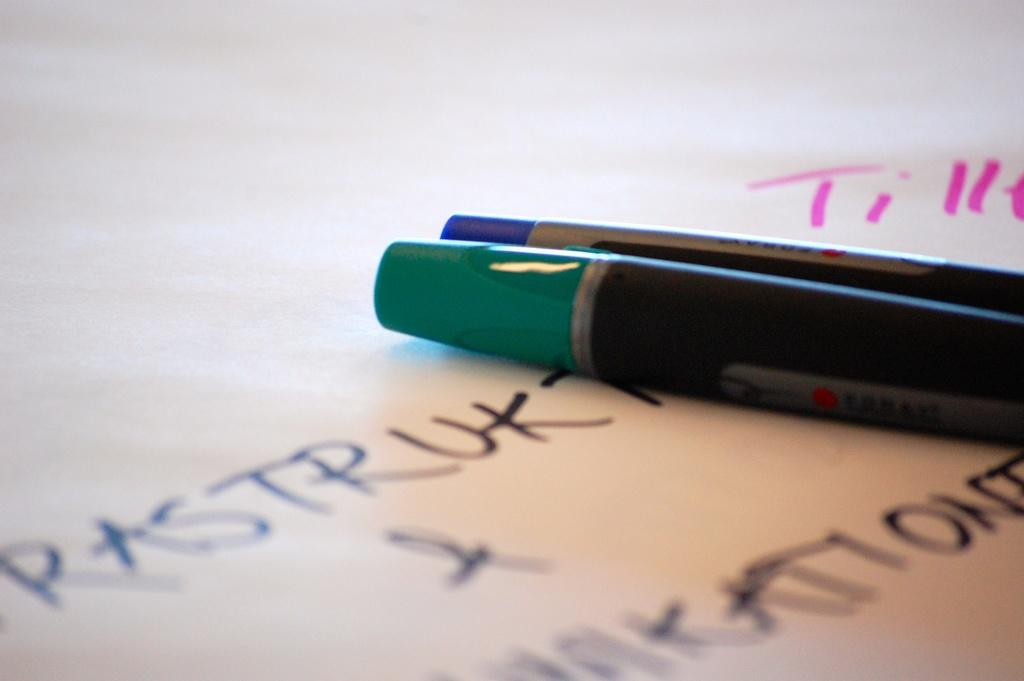What objects are present in the image that can be used for writing? There are two pens in the image that can be used for writing. What is the pens placed on or near in the image? There is a paper in the image. Can you describe the paper in the image? The paper in the image has writing on it. What type of house is visible in the background of the image? There is no house visible in the image; it only features two pens, a paper, and writing. Can you tell me how many horses are present in the image? There are no horses present in the image. 